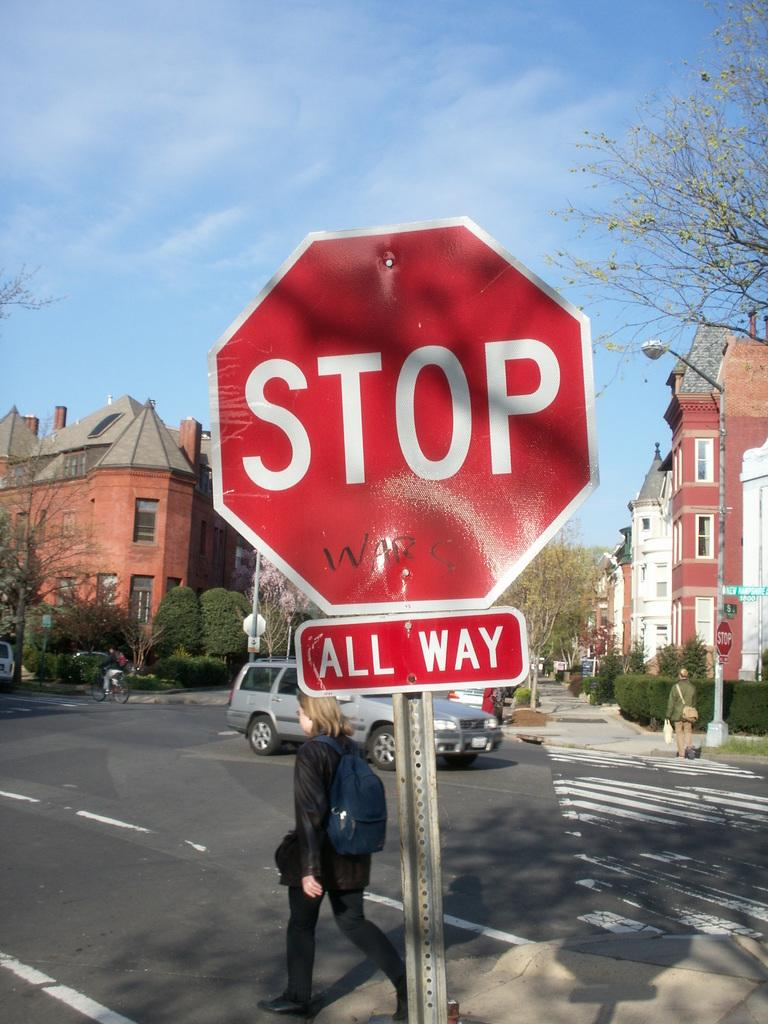<image>
Summarize the visual content of the image. A, Stop All Way, sign at an intersection with people and vehicles behind it. 